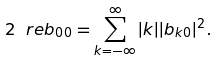Convert formula to latex. <formula><loc_0><loc_0><loc_500><loc_500>2 \ r e b _ { 0 0 } = \sum _ { k = - \infty } ^ { \infty } | k | | b _ { k 0 } | ^ { 2 } .</formula> 